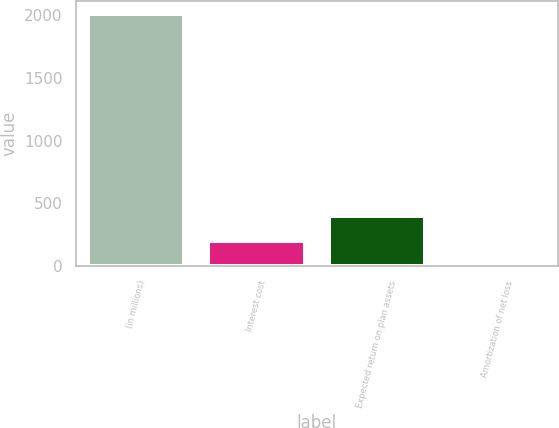Convert chart to OTSL. <chart><loc_0><loc_0><loc_500><loc_500><bar_chart><fcel>(in millions)<fcel>Interest cost<fcel>Expected return on plan assets<fcel>Amortization of net loss<nl><fcel>2011<fcel>202<fcel>403<fcel>1<nl></chart> 